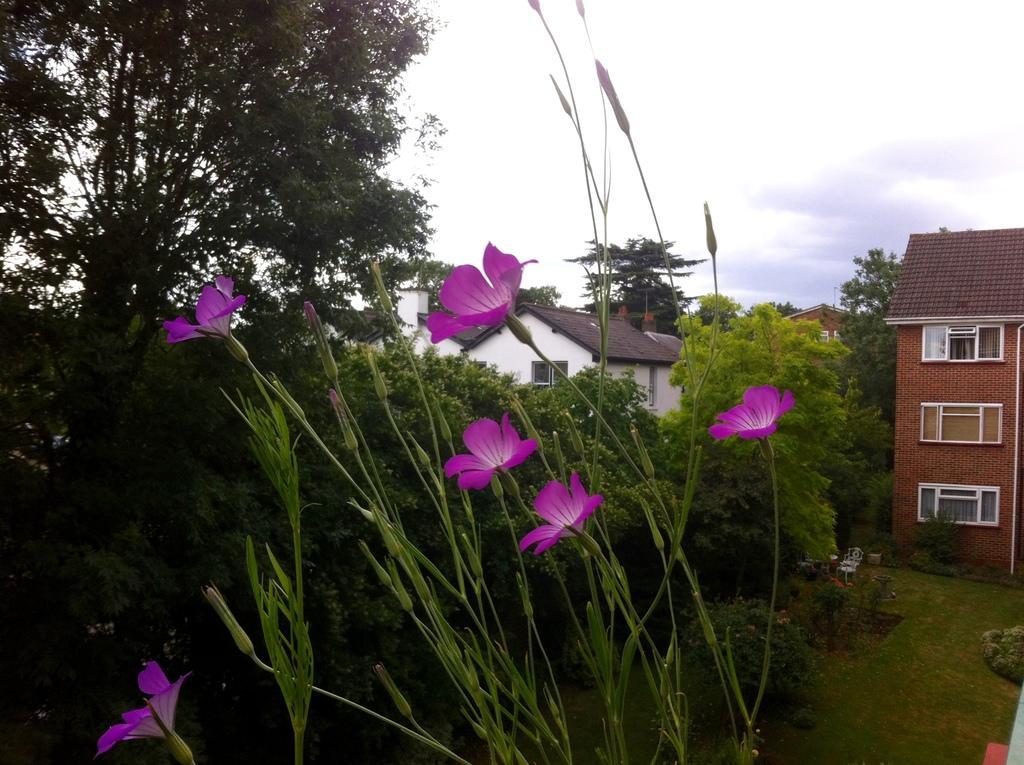Please provide a concise description of this image. In this image there are buildings and trees. At the bottom there are plants and we can see flowers. In the background there is sky. 